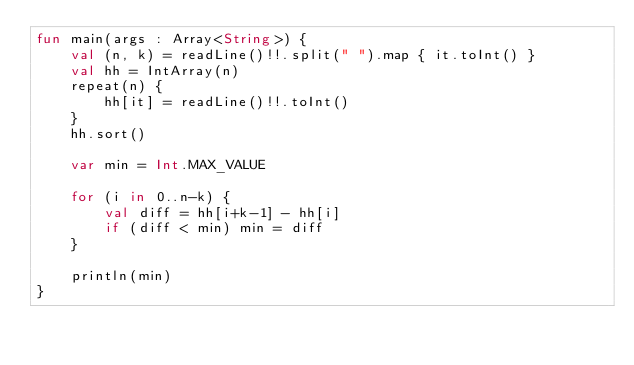Convert code to text. <code><loc_0><loc_0><loc_500><loc_500><_Kotlin_>fun main(args : Array<String>) {
    val (n, k) = readLine()!!.split(" ").map { it.toInt() }
    val hh = IntArray(n)
    repeat(n) {
        hh[it] = readLine()!!.toInt()
    }
    hh.sort()

    var min = Int.MAX_VALUE

    for (i in 0..n-k) {
        val diff = hh[i+k-1] - hh[i]
        if (diff < min) min = diff
    }

    println(min)
}</code> 